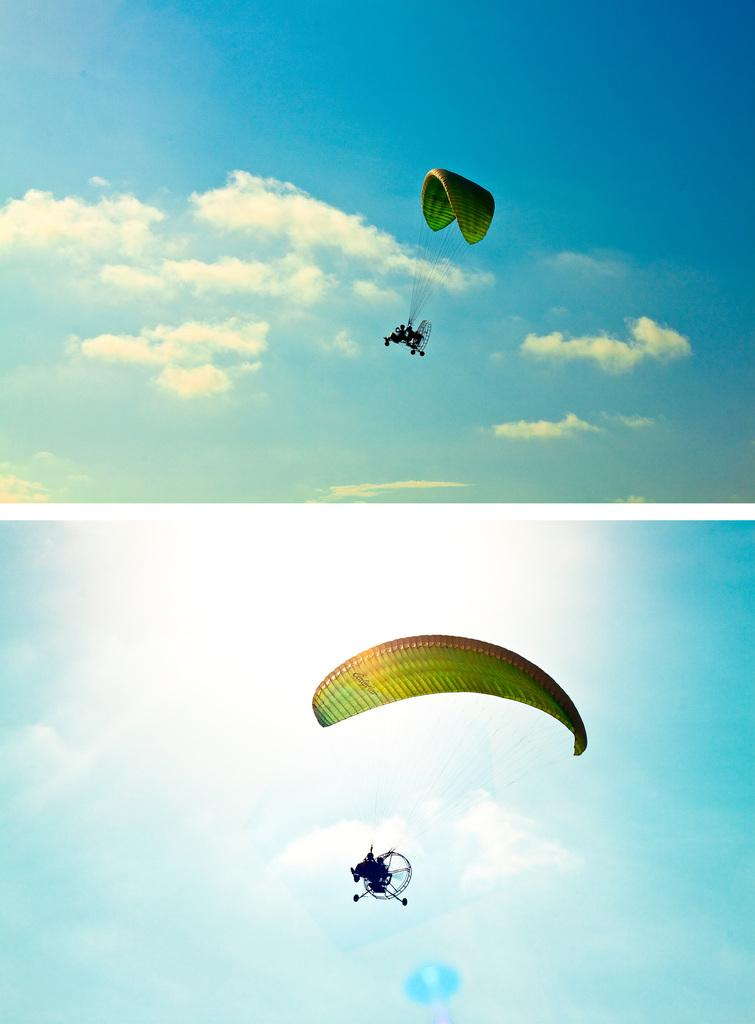How many pictures are included in the collage? The image is a collage of two pictures. What activity is being performed by the person in the bottom picture? In the bottom picture, there is a person para riding. What activity is being performed by the people in the top picture? In the top picture, there are people para riding. What is a common element in both pictures? Both images contain clouds and sky. What type of coal is being mined in the image? There is no coal or mining activity present in the image. Who is sitting on the throne in the image? There is no throne or royal figure present in the image. 